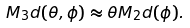Convert formula to latex. <formula><loc_0><loc_0><loc_500><loc_500>M _ { 3 } d ( \theta , \phi ) \approx \theta M _ { 2 } d ( \phi ) .</formula> 